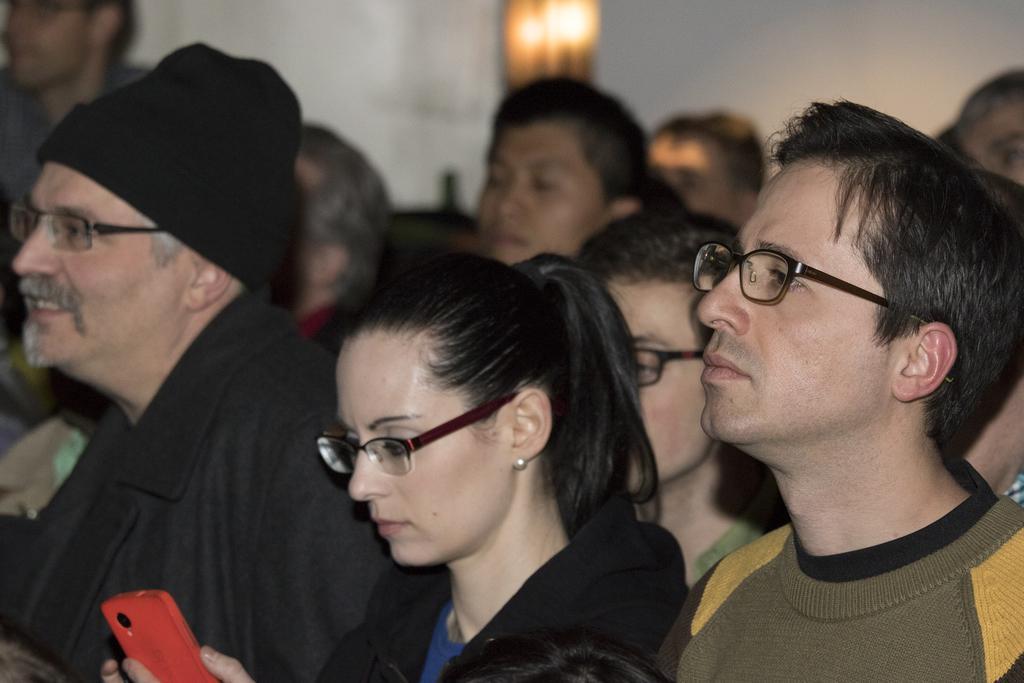Please provide a concise description of this image. In this picture I can see few people among them few people are wearing spectacles. 